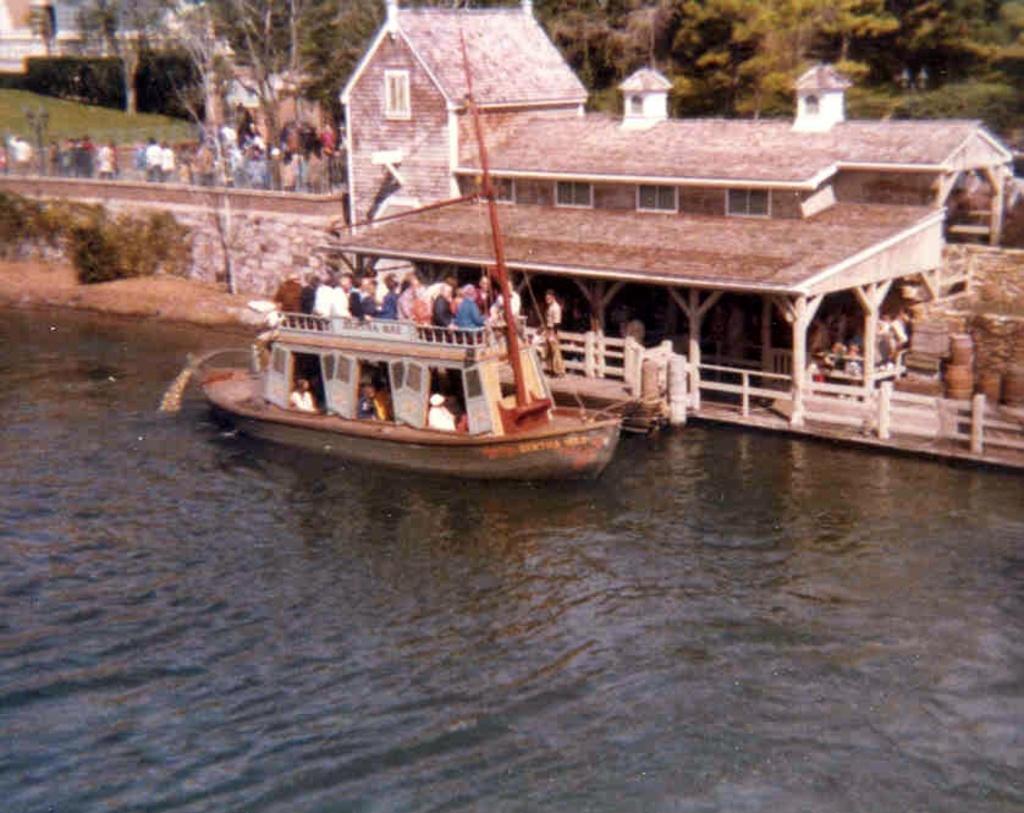Can you describe this image briefly? In this image I can see the boat on the water. I can see few people in the boat. In the background I can see the railing, buildings, few more people with different color dresses and many trees. 